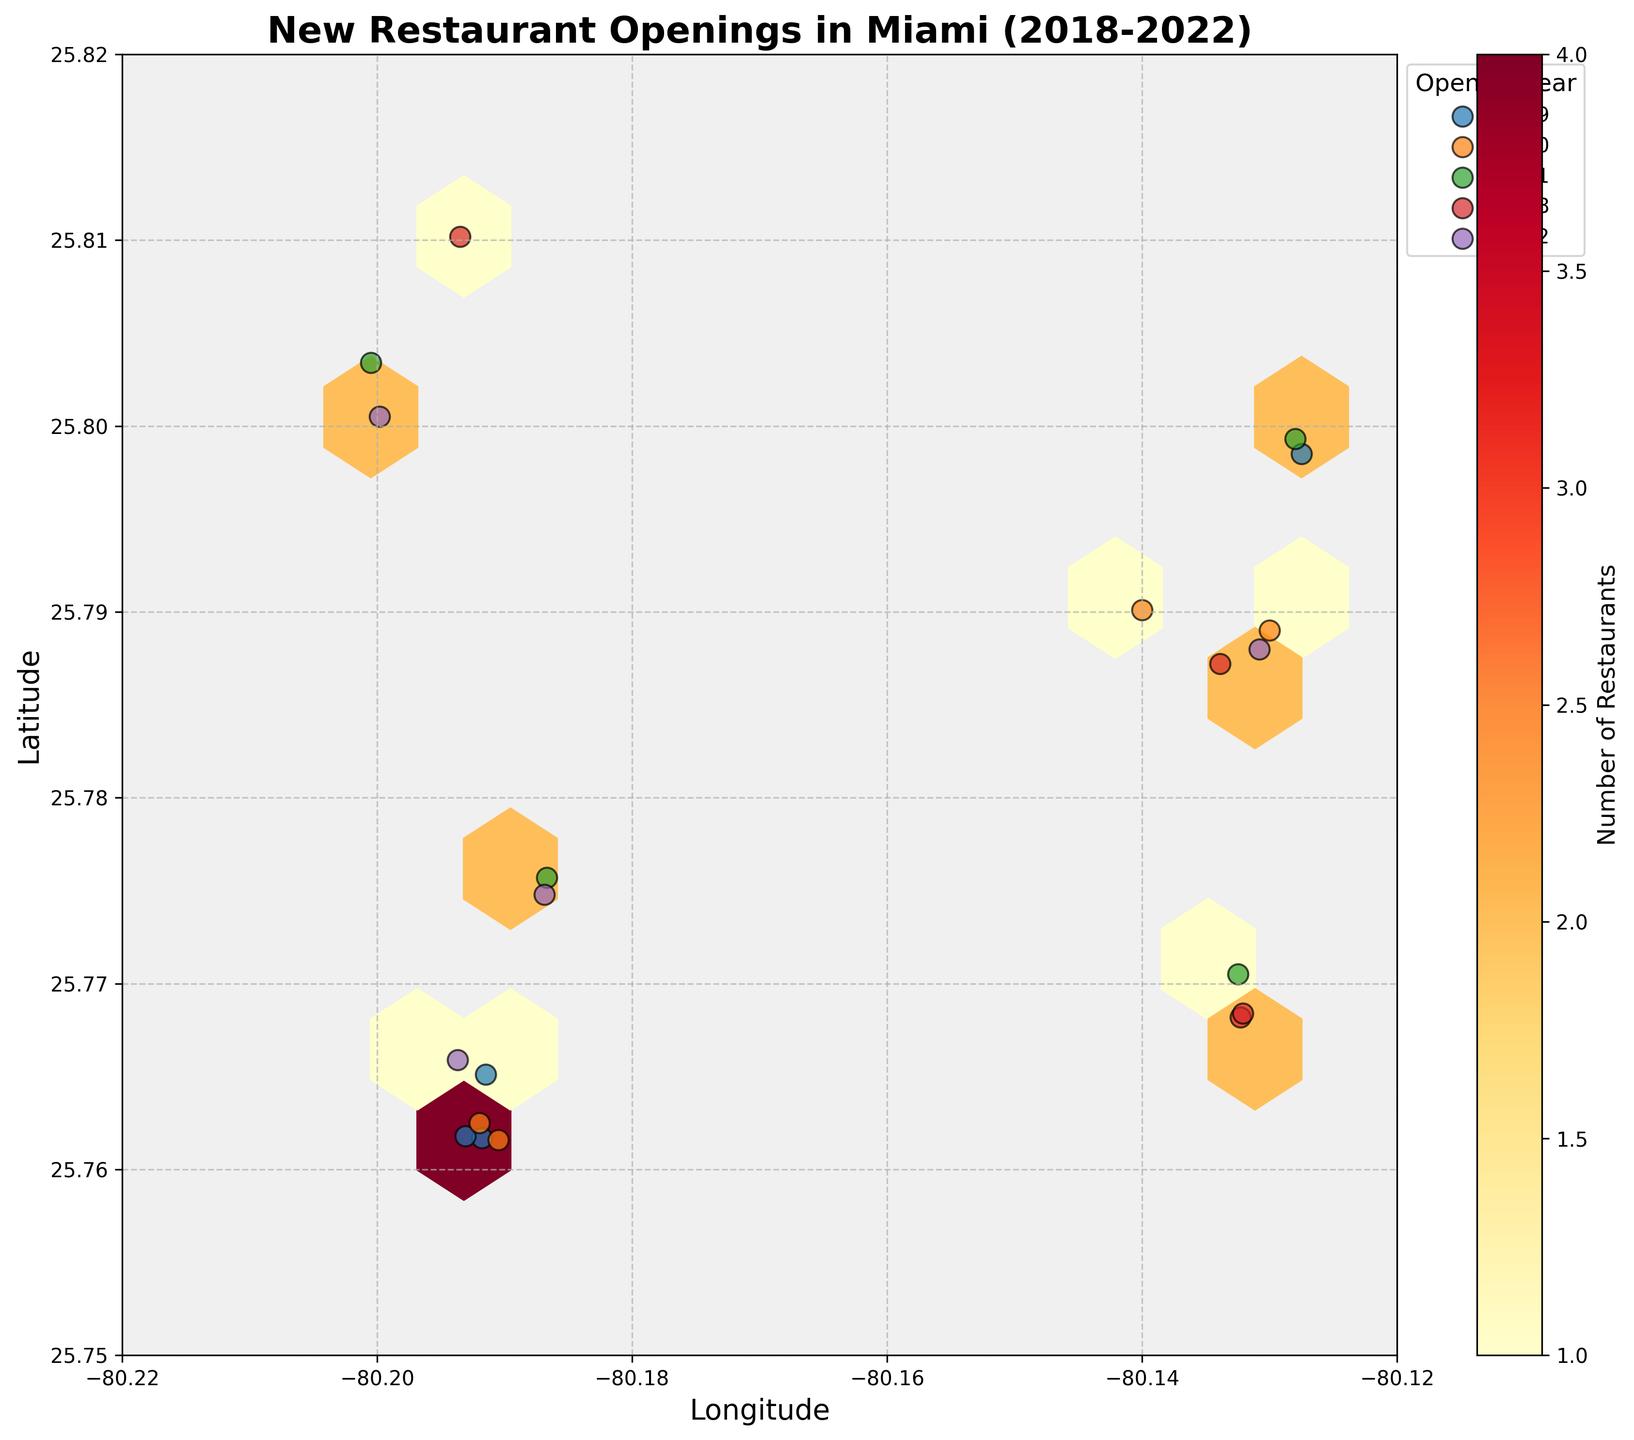What is the title of the plot? The title is the text at the top of the figure, typically used to describe what the figure represents.
Answer: New Restaurant Openings in Miami (2018-2022) What is the color range used in the hexbin plot? The hexbin plot color range is usually depicted in the figure's color bar, indicating bins from a lower (yellow) to a higher (red) density of points.
Answer: Yellow to Red How many restaurants opened in 2021? Look at the plot's legend for the years and count the scatter markers for 2021.
Answer: 4 Which year had the fewest restaurant openings? Compare the number of markers for each year as shown in the legend.
Answer: 2018 Which area in Miami had the highest density of new restaurant openings? Look for the hexagon bin(s) with the darkest color, indicating the highest frequency.
Answer: Around the latitude 25.76 - 25.77 and longitude -80.19 Are there more restaurant openings closer to the center or the edges of the city latitude-longitude range? Check the hexbin plot concentration visually; more concentrated bins suggest more openings.
Answer: Closer to the center What is the rough range of latitude and longitude values shown in the plot? Read the numeric values on the x and y axis, indicating the longitude and latitude range.
Answer: Latitude: 25.75 to 25.82, Longitude: -80.22 to -80.12 Compare the number of restaurant openings in 2019 and 2020. Which year had more openings? Count the markers in the legend for both 2019 and 2020 and compare the counts.
Answer: 2019 What does each hexagon in the plot represent? A single hexagon represents a bin of geographic space, and its color indicates the number of restaurant openings in that space based on the color bar.
Answer: Number of restaurant openings In which year was there an increase in the number of restaurant openings compared to the previous year? Compare the count of scatter markers year by year as per the legend. Look for an increase from one year to the next.
Answer: 2021 compared to 2020 